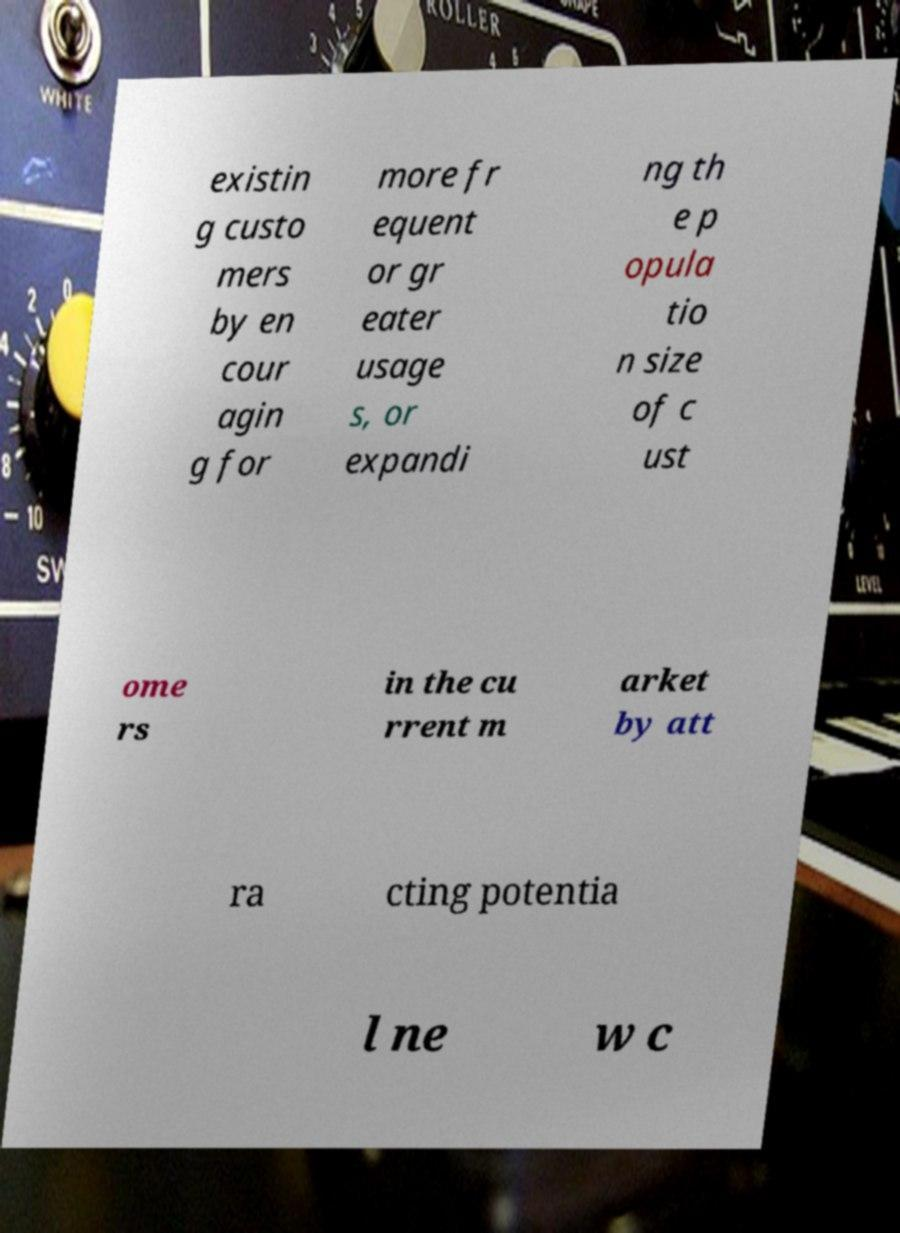Can you read and provide the text displayed in the image?This photo seems to have some interesting text. Can you extract and type it out for me? existin g custo mers by en cour agin g for more fr equent or gr eater usage s, or expandi ng th e p opula tio n size of c ust ome rs in the cu rrent m arket by att ra cting potentia l ne w c 